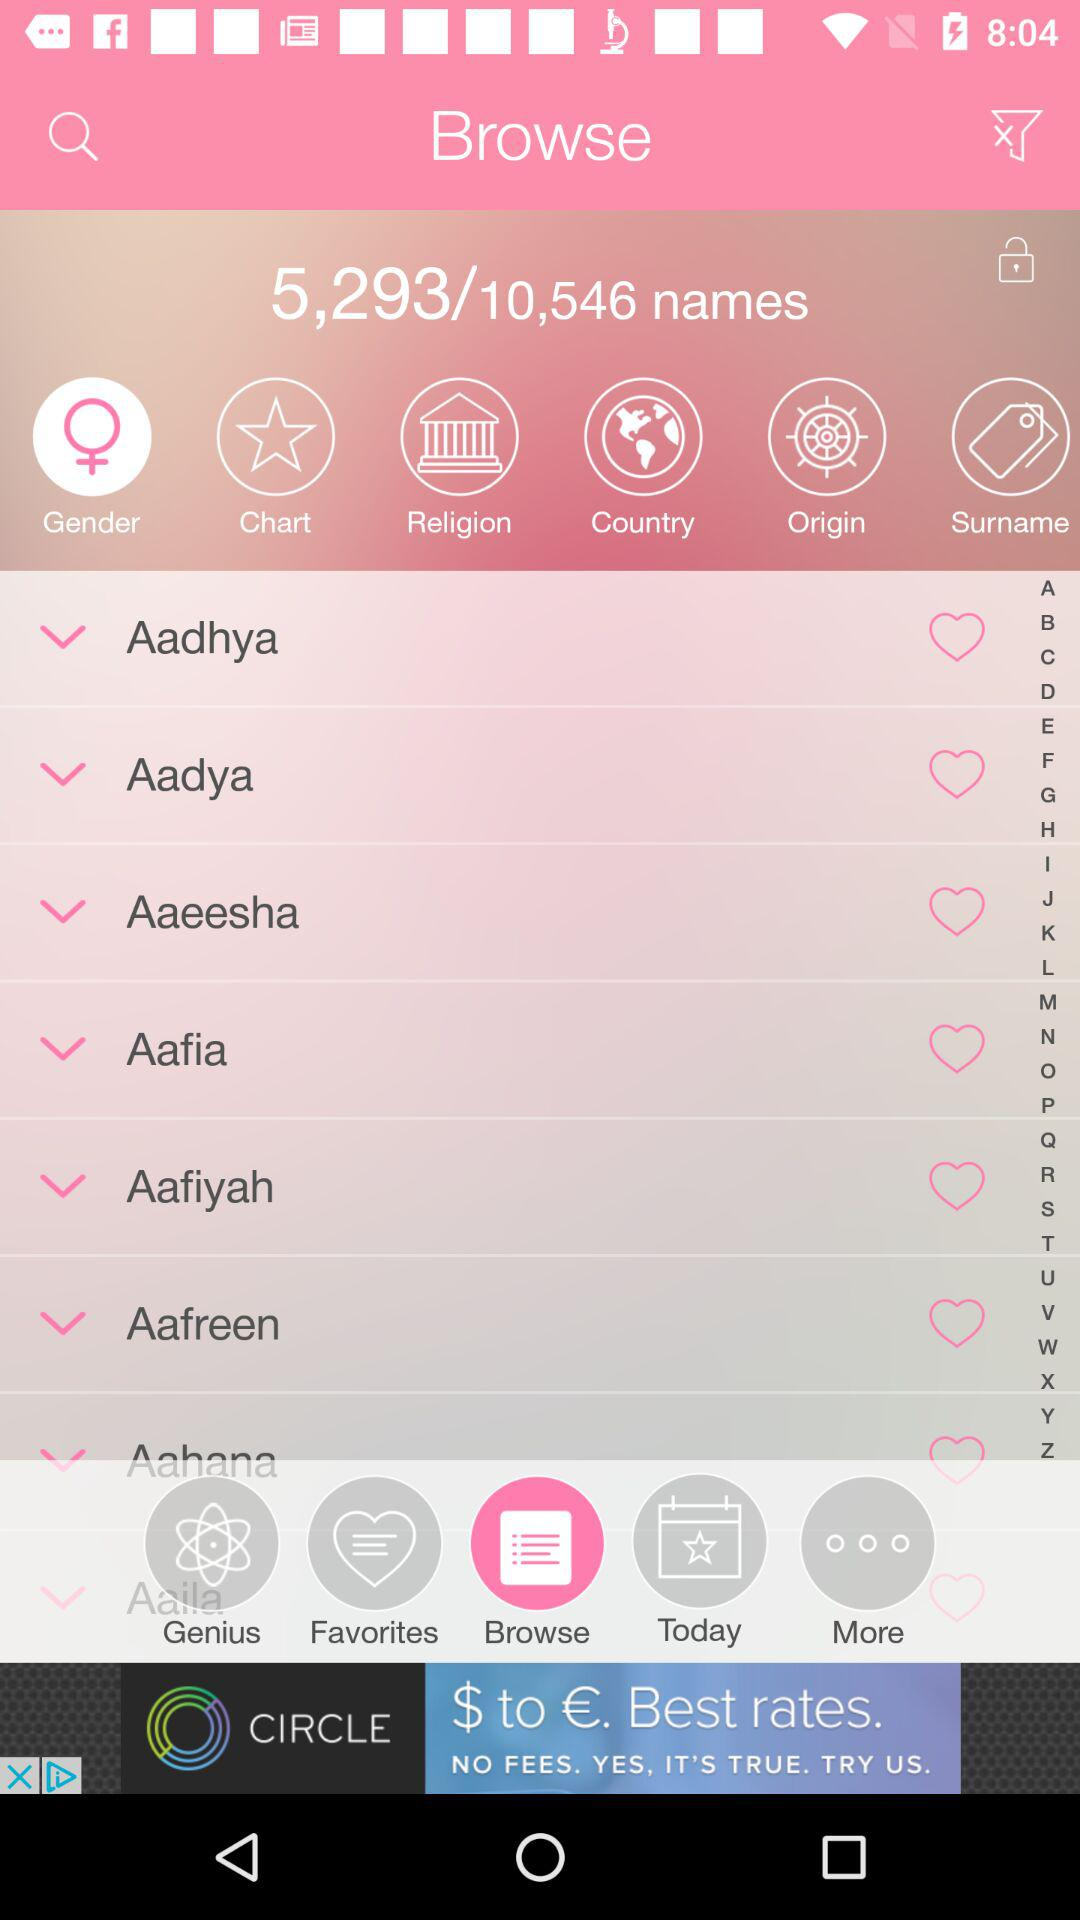How many names in total are there on the screen? There are 10,546 names in total. 